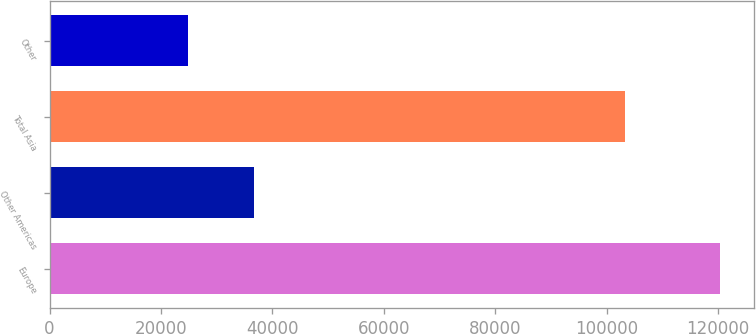<chart> <loc_0><loc_0><loc_500><loc_500><bar_chart><fcel>Europe<fcel>Other Americas<fcel>Total Asia<fcel>Other<nl><fcel>120362<fcel>36666<fcel>103192<fcel>24816<nl></chart> 